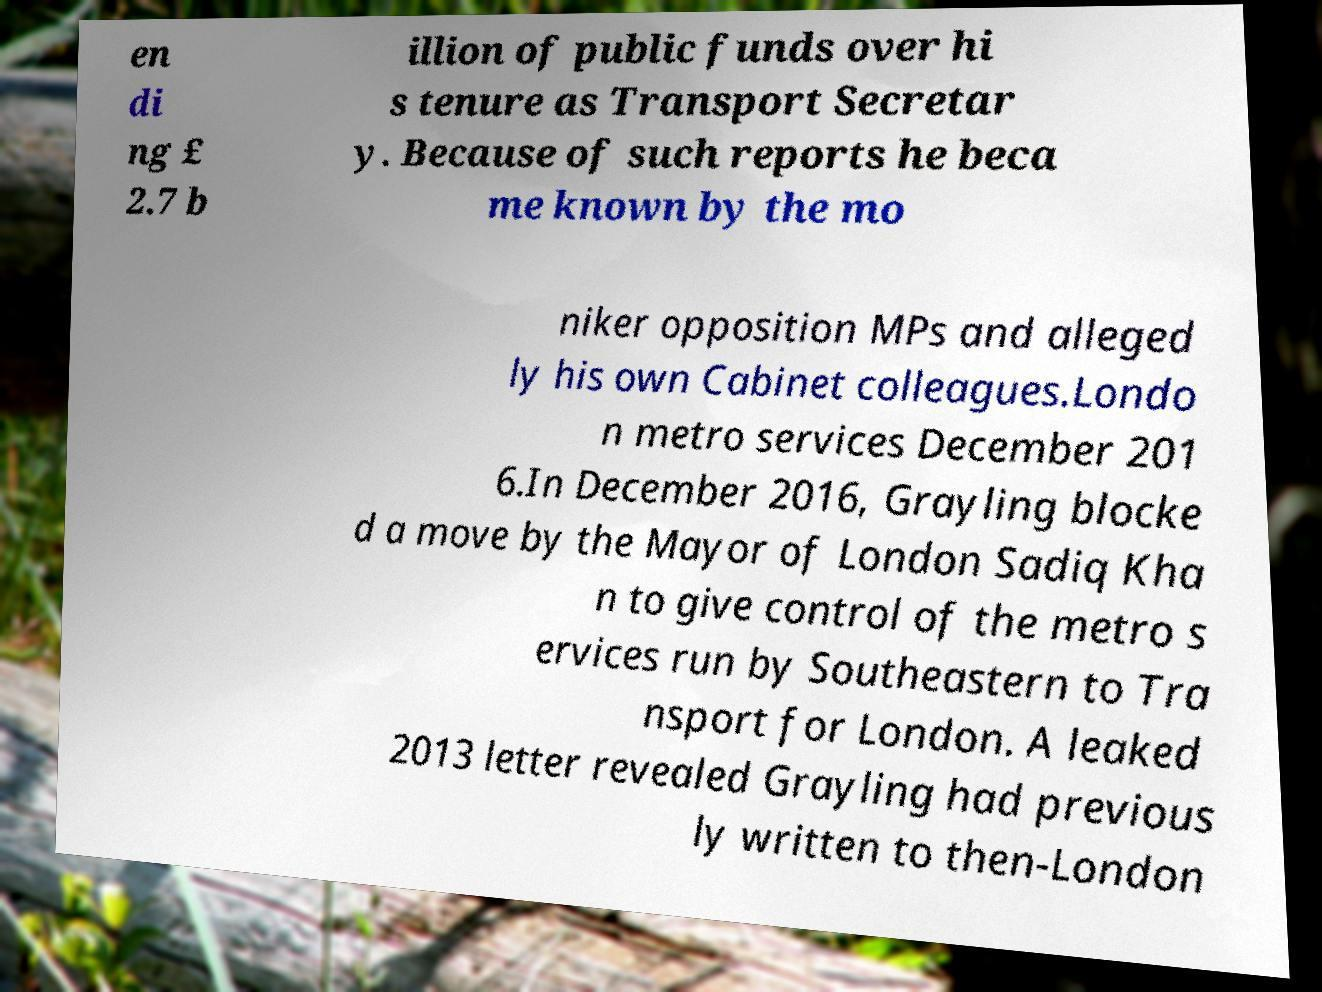What messages or text are displayed in this image? I need them in a readable, typed format. en di ng £ 2.7 b illion of public funds over hi s tenure as Transport Secretar y. Because of such reports he beca me known by the mo niker opposition MPs and alleged ly his own Cabinet colleagues.Londo n metro services December 201 6.In December 2016, Grayling blocke d a move by the Mayor of London Sadiq Kha n to give control of the metro s ervices run by Southeastern to Tra nsport for London. A leaked 2013 letter revealed Grayling had previous ly written to then-London 